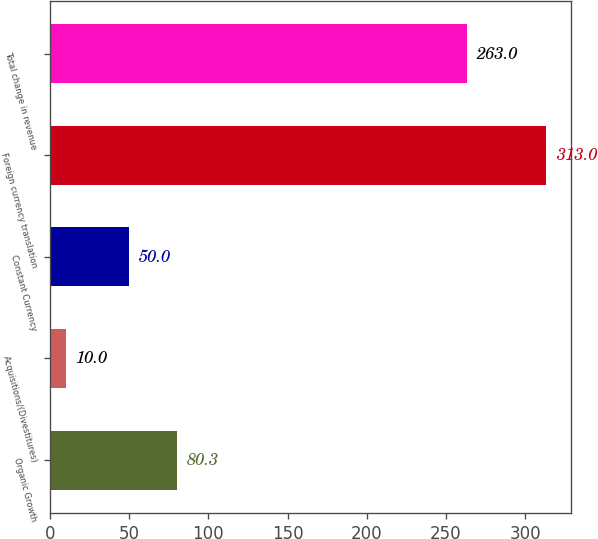Convert chart. <chart><loc_0><loc_0><loc_500><loc_500><bar_chart><fcel>Organic Growth<fcel>Acquisitions/(Divestitures)<fcel>Constant Currency<fcel>Foreign currency translation<fcel>Total change in revenue<nl><fcel>80.3<fcel>10<fcel>50<fcel>313<fcel>263<nl></chart> 